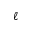Convert formula to latex. <formula><loc_0><loc_0><loc_500><loc_500>\ell</formula> 